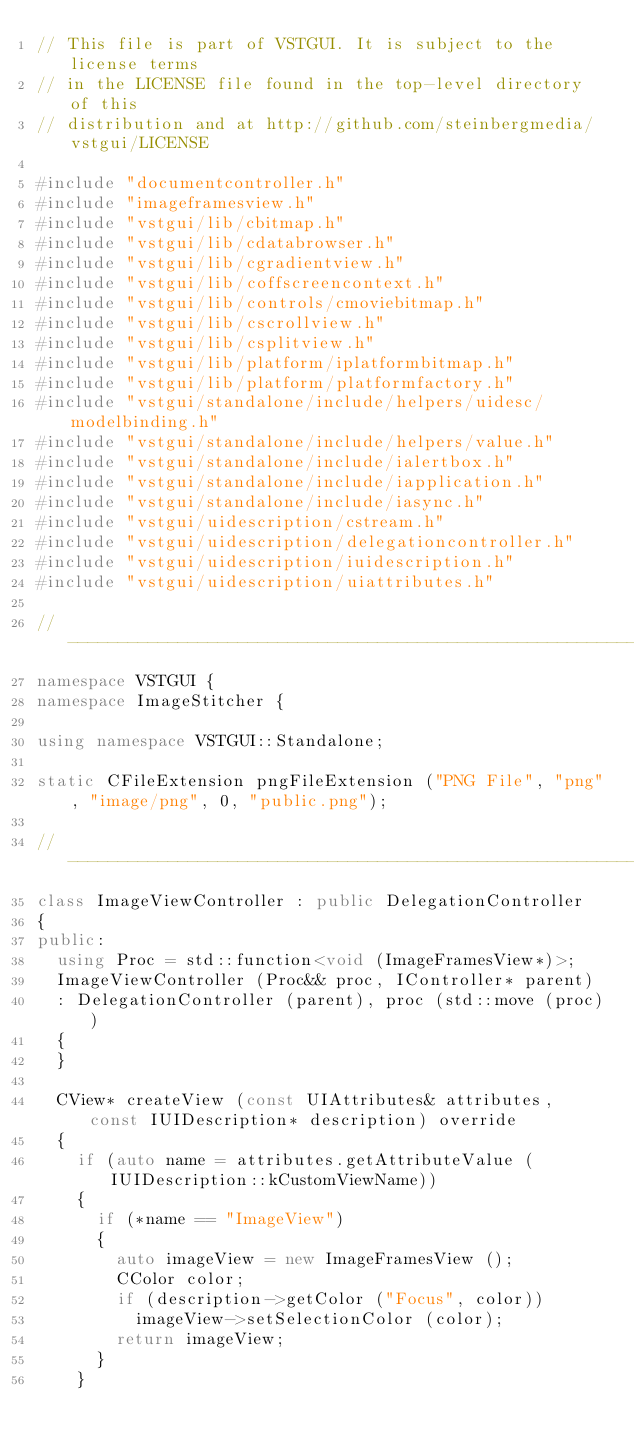<code> <loc_0><loc_0><loc_500><loc_500><_C++_>// This file is part of VSTGUI. It is subject to the license terms
// in the LICENSE file found in the top-level directory of this
// distribution and at http://github.com/steinbergmedia/vstgui/LICENSE

#include "documentcontroller.h"
#include "imageframesview.h"
#include "vstgui/lib/cbitmap.h"
#include "vstgui/lib/cdatabrowser.h"
#include "vstgui/lib/cgradientview.h"
#include "vstgui/lib/coffscreencontext.h"
#include "vstgui/lib/controls/cmoviebitmap.h"
#include "vstgui/lib/cscrollview.h"
#include "vstgui/lib/csplitview.h"
#include "vstgui/lib/platform/iplatformbitmap.h"
#include "vstgui/lib/platform/platformfactory.h"
#include "vstgui/standalone/include/helpers/uidesc/modelbinding.h"
#include "vstgui/standalone/include/helpers/value.h"
#include "vstgui/standalone/include/ialertbox.h"
#include "vstgui/standalone/include/iapplication.h"
#include "vstgui/standalone/include/iasync.h"
#include "vstgui/uidescription/cstream.h"
#include "vstgui/uidescription/delegationcontroller.h"
#include "vstgui/uidescription/iuidescription.h"
#include "vstgui/uidescription/uiattributes.h"

//------------------------------------------------------------------------
namespace VSTGUI {
namespace ImageStitcher {

using namespace VSTGUI::Standalone;

static CFileExtension pngFileExtension ("PNG File", "png", "image/png", 0, "public.png");

//------------------------------------------------------------------------
class ImageViewController : public DelegationController
{
public:
	using Proc = std::function<void (ImageFramesView*)>;
	ImageViewController (Proc&& proc, IController* parent)
	: DelegationController (parent), proc (std::move (proc))
	{
	}

	CView* createView (const UIAttributes& attributes, const IUIDescription* description) override
	{
		if (auto name = attributes.getAttributeValue (IUIDescription::kCustomViewName))
		{
			if (*name == "ImageView")
			{
				auto imageView = new ImageFramesView ();
				CColor color;
				if (description->getColor ("Focus", color))
					imageView->setSelectionColor (color);
				return imageView;
			}
		}</code> 